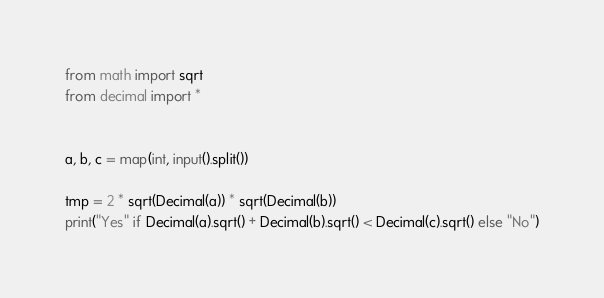Convert code to text. <code><loc_0><loc_0><loc_500><loc_500><_Python_>from math import sqrt
from decimal import *


a, b, c = map(int, input().split())

tmp = 2 * sqrt(Decimal(a)) * sqrt(Decimal(b))
print("Yes" if Decimal(a).sqrt() + Decimal(b).sqrt() < Decimal(c).sqrt() else "No")
</code> 